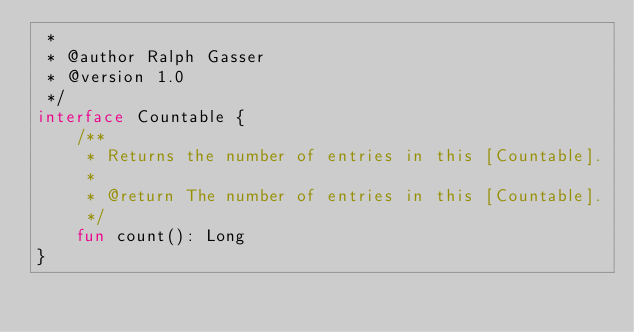Convert code to text. <code><loc_0><loc_0><loc_500><loc_500><_Kotlin_> *
 * @author Ralph Gasser
 * @version 1.0
 */
interface Countable {
    /**
     * Returns the number of entries in this [Countable].
     *
     * @return The number of entries in this [Countable].
     */
    fun count(): Long
}</code> 